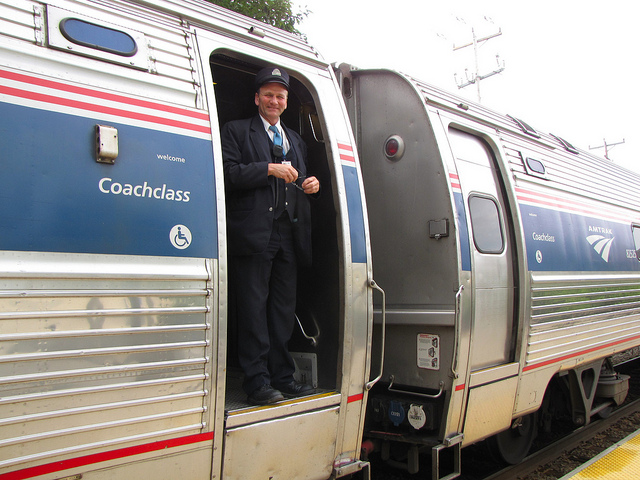Please identify all text content in this image. Welcome Coachclass Welcome coachclass AMTRAK 